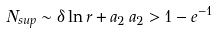<formula> <loc_0><loc_0><loc_500><loc_500>N _ { s u p } \sim \delta \ln r + a _ { 2 } \, a _ { 2 } > 1 - e ^ { - 1 }</formula> 